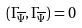<formula> <loc_0><loc_0><loc_500><loc_500>( \Gamma _ { \overline { \Psi } } , \Gamma _ { \overline { \Psi } } ) = 0</formula> 